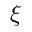<formula> <loc_0><loc_0><loc_500><loc_500>\xi</formula> 